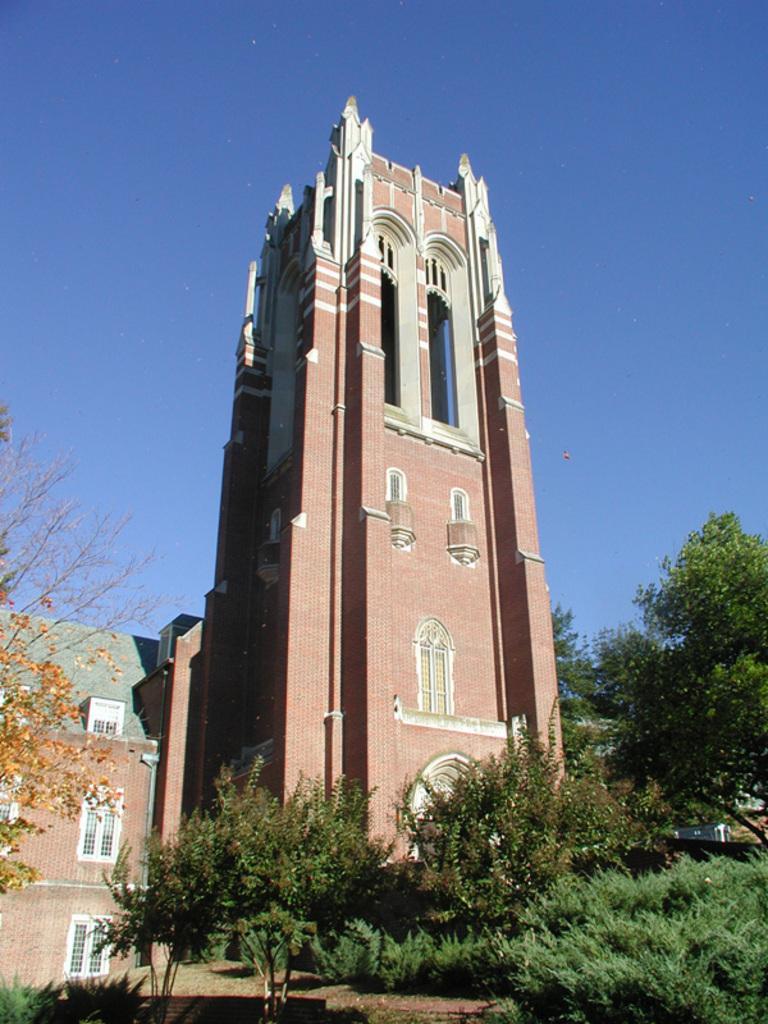How would you summarize this image in a sentence or two? In this image there is a building, trees, plants, blue sky and objects. 